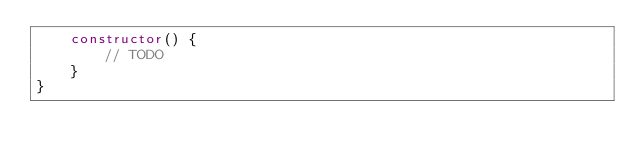Convert code to text. <code><loc_0><loc_0><loc_500><loc_500><_TypeScript_>    constructor() {
        // TODO
    }
}
</code> 